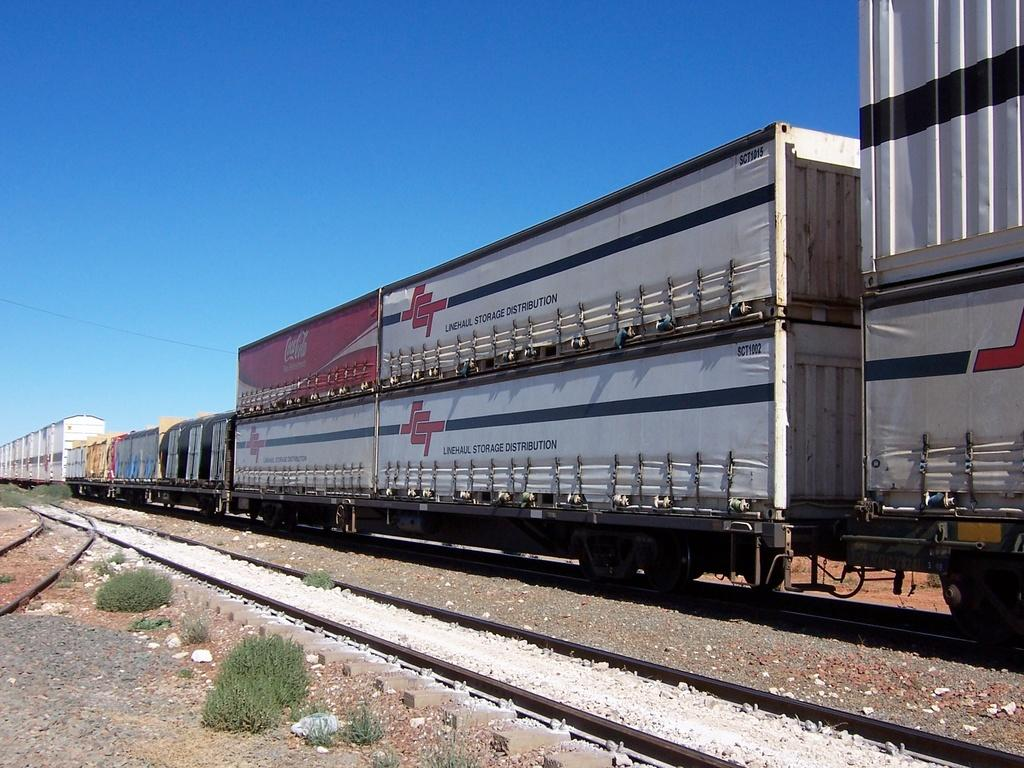What is located in the foreground of the image? In the foreground of the image, there are plants, stones, and railway tracks. What is on the railway tracks? There is a goods carrier on the railway tracks. What can be seen in the sky in the image? The sky is visible at the top of the image. What type of elbow can be seen supporting the goods carrier in the image? There is no elbow present in the image; it features a goods carrier on railway tracks. Can you tell me how many cans are stacked on the goods carrier in the image? There is no information about cans on the goods carrier in the image; it only shows a goods carrier on railway tracks. 